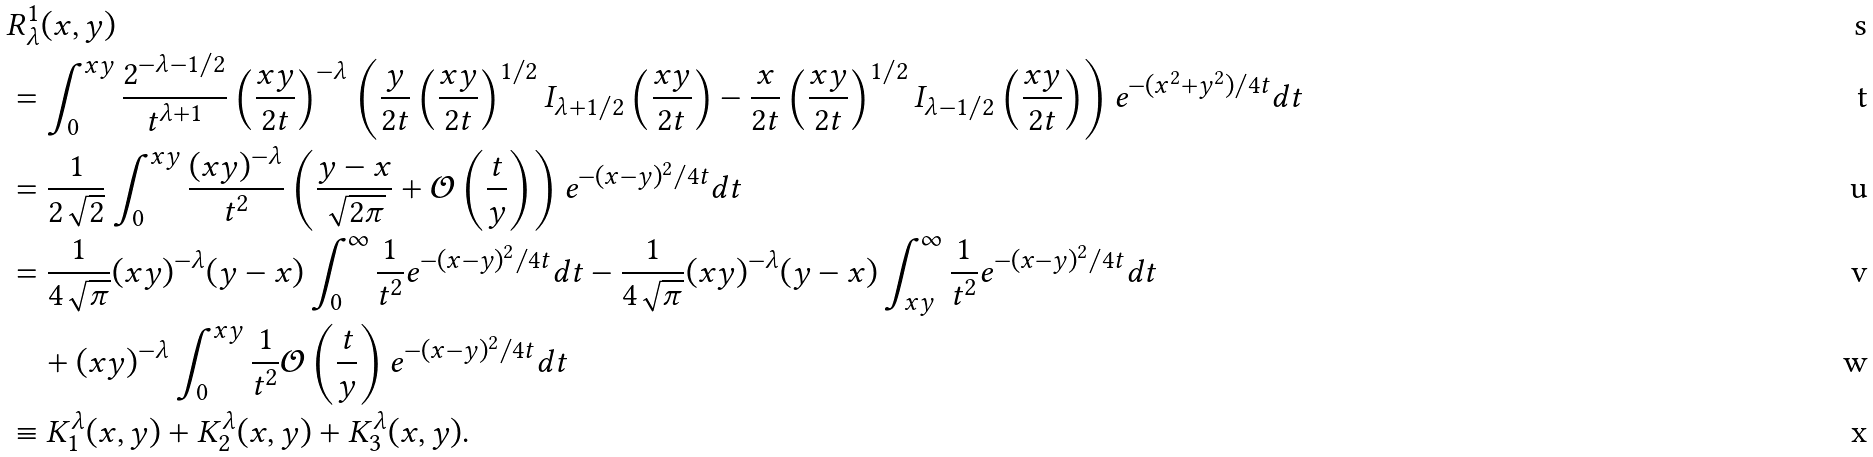Convert formula to latex. <formula><loc_0><loc_0><loc_500><loc_500>& R _ { \lambda } ^ { 1 } ( x , y ) \\ & = \int _ { 0 } ^ { x y } \frac { 2 ^ { - \lambda - 1 \slash 2 } } { t ^ { \lambda + 1 } } \left ( \frac { x y } { 2 t } \right ) ^ { - \lambda } \left ( \frac { y } { 2 t } \left ( \frac { x y } { 2 t } \right ) ^ { 1 / 2 } I _ { \lambda + 1 / 2 } \left ( \frac { x y } { 2 t } \right ) - \frac { x } { 2 t } \left ( \frac { x y } { 2 t } \right ) ^ { 1 / 2 } I _ { \lambda - 1 / 2 } \left ( \frac { x y } { 2 t } \right ) \right ) e ^ { - ( x ^ { 2 } + y ^ { 2 } ) / 4 t } d t \\ & = \frac { 1 } { 2 \sqrt { 2 } } \int _ { 0 } ^ { x y } \frac { ( x y ) ^ { - \lambda } } { t ^ { 2 } } \left ( \frac { y - x } { \sqrt { 2 \pi } } + \mathcal { O } \left ( \frac { t } { y } \right ) \right ) e ^ { - ( x - y ) ^ { 2 } / 4 t } d t \\ & = \frac { 1 } { 4 \sqrt { \pi } } ( x y ) ^ { - \lambda } ( y - x ) \int _ { 0 } ^ { \infty } \frac { 1 } { t ^ { 2 } } e ^ { - ( x - y ) ^ { 2 } / 4 t } d t - \frac { 1 } { 4 \sqrt { \pi } } ( x y ) ^ { - \lambda } ( y - x ) \int _ { x y } ^ { \infty } \frac { 1 } { t ^ { 2 } } e ^ { - ( x - y ) ^ { 2 } / 4 t } d t \\ & \quad + ( x y ) ^ { - \lambda } \int _ { 0 } ^ { x y } \frac { 1 } { t ^ { 2 } } \mathcal { O } \left ( \frac { t } { y } \right ) e ^ { - ( x - y ) ^ { 2 } / 4 t } d t \\ & \equiv K ^ { \lambda } _ { 1 } ( x , y ) + K ^ { \lambda } _ { 2 } ( x , y ) + K ^ { \lambda } _ { 3 } ( x , y ) .</formula> 